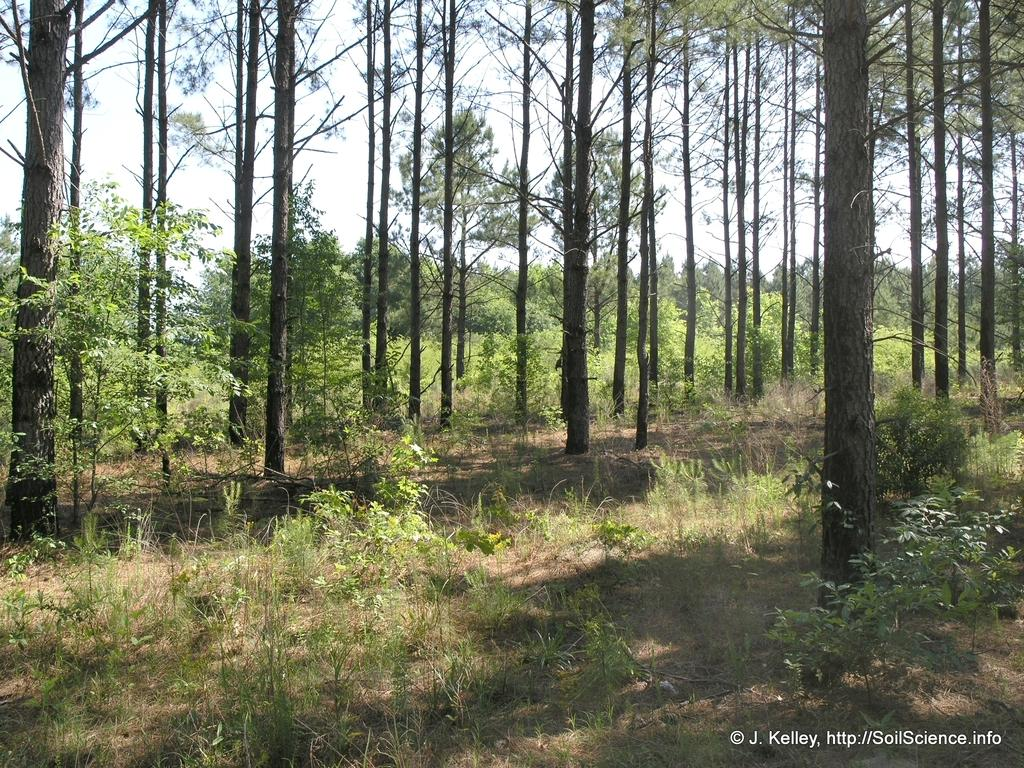What type of vegetation can be seen in the image? There are trees in the image. What is the color of the grass in the image? There is green grass in the image. What is the color of the sky in the image? The sky is white in color. How many books can be seen on the trees in the image? There are no books present in the image; it features trees and grass. What type of finger is visible in the image? There is no finger visible in the image. 